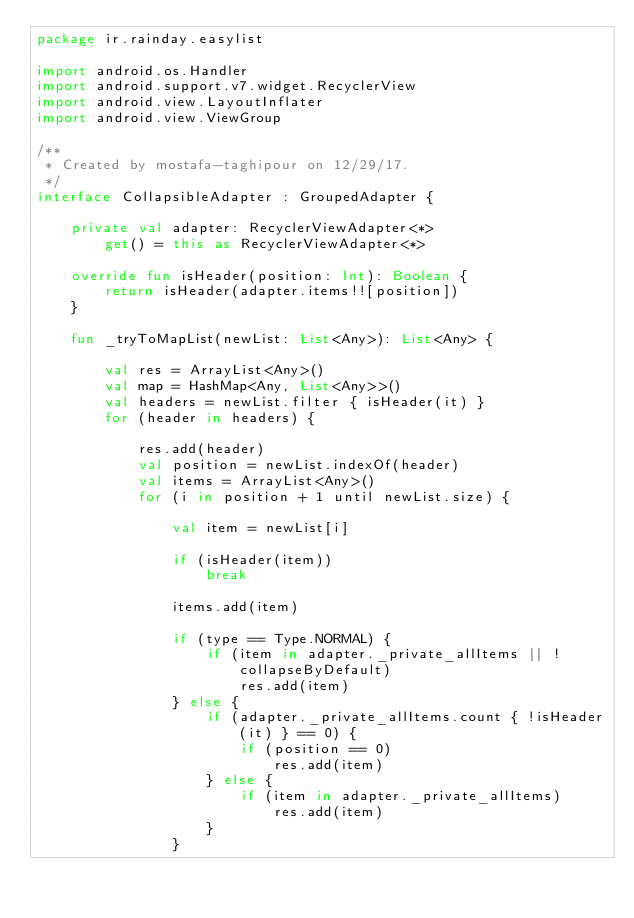Convert code to text. <code><loc_0><loc_0><loc_500><loc_500><_Kotlin_>package ir.rainday.easylist

import android.os.Handler
import android.support.v7.widget.RecyclerView
import android.view.LayoutInflater
import android.view.ViewGroup

/**
 * Created by mostafa-taghipour on 12/29/17.
 */
interface CollapsibleAdapter : GroupedAdapter {

    private val adapter: RecyclerViewAdapter<*>
        get() = this as RecyclerViewAdapter<*>

    override fun isHeader(position: Int): Boolean {
        return isHeader(adapter.items!![position])
    }

    fun _tryToMapList(newList: List<Any>): List<Any> {

        val res = ArrayList<Any>()
        val map = HashMap<Any, List<Any>>()
        val headers = newList.filter { isHeader(it) }
        for (header in headers) {

            res.add(header)
            val position = newList.indexOf(header)
            val items = ArrayList<Any>()
            for (i in position + 1 until newList.size) {

                val item = newList[i]

                if (isHeader(item))
                    break

                items.add(item)

                if (type == Type.NORMAL) {
                    if (item in adapter._private_allItems || !collapseByDefault)
                        res.add(item)
                } else {
                    if (adapter._private_allItems.count { !isHeader(it) } == 0) {
                        if (position == 0)
                            res.add(item)
                    } else {
                        if (item in adapter._private_allItems)
                            res.add(item)
                    }
                }</code> 